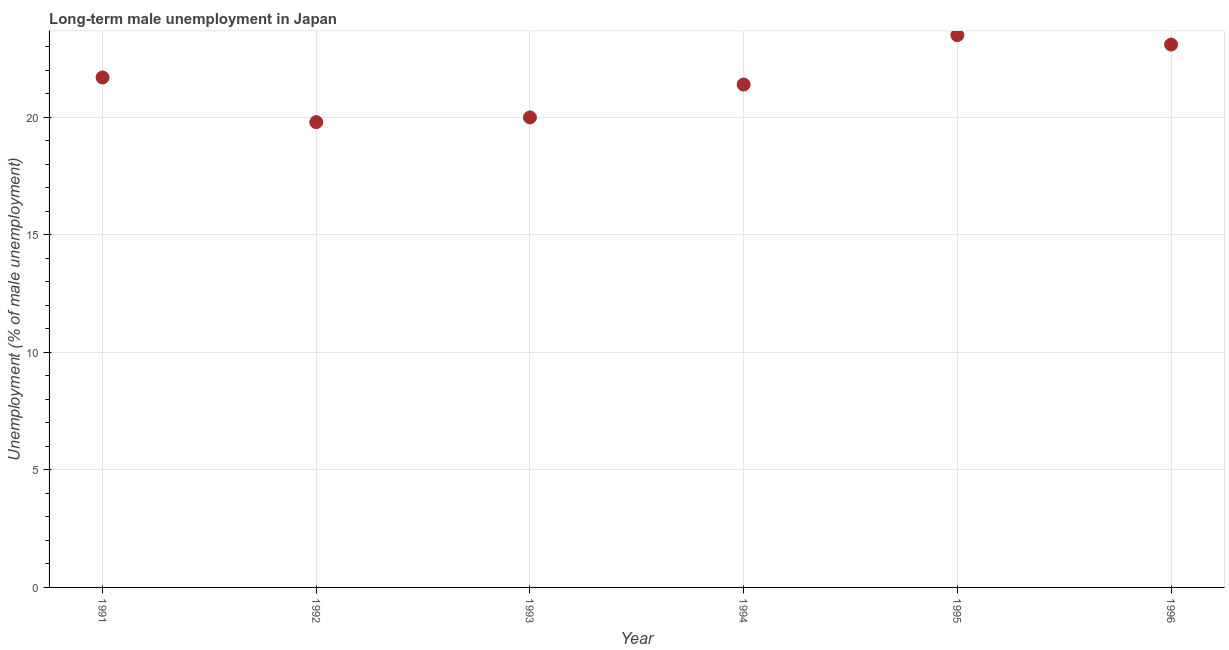What is the long-term male unemployment in 1992?
Provide a short and direct response. 19.8. Across all years, what is the minimum long-term male unemployment?
Your answer should be very brief. 19.8. In which year was the long-term male unemployment maximum?
Make the answer very short. 1995. What is the sum of the long-term male unemployment?
Offer a terse response. 129.5. What is the difference between the long-term male unemployment in 1992 and 1994?
Your answer should be compact. -1.6. What is the average long-term male unemployment per year?
Offer a terse response. 21.58. What is the median long-term male unemployment?
Ensure brevity in your answer.  21.55. Do a majority of the years between 1995 and 1993 (inclusive) have long-term male unemployment greater than 16 %?
Give a very brief answer. No. What is the ratio of the long-term male unemployment in 1991 to that in 1993?
Make the answer very short. 1.09. Is the long-term male unemployment in 1993 less than that in 1996?
Keep it short and to the point. Yes. What is the difference between the highest and the second highest long-term male unemployment?
Your answer should be very brief. 0.4. What is the difference between the highest and the lowest long-term male unemployment?
Provide a short and direct response. 3.7. In how many years, is the long-term male unemployment greater than the average long-term male unemployment taken over all years?
Keep it short and to the point. 3. How many dotlines are there?
Provide a short and direct response. 1. Are the values on the major ticks of Y-axis written in scientific E-notation?
Keep it short and to the point. No. Does the graph contain grids?
Ensure brevity in your answer.  Yes. What is the title of the graph?
Your answer should be compact. Long-term male unemployment in Japan. What is the label or title of the X-axis?
Ensure brevity in your answer.  Year. What is the label or title of the Y-axis?
Offer a terse response. Unemployment (% of male unemployment). What is the Unemployment (% of male unemployment) in 1991?
Provide a short and direct response. 21.7. What is the Unemployment (% of male unemployment) in 1992?
Your response must be concise. 19.8. What is the Unemployment (% of male unemployment) in 1993?
Offer a terse response. 20. What is the Unemployment (% of male unemployment) in 1994?
Provide a succinct answer. 21.4. What is the Unemployment (% of male unemployment) in 1995?
Provide a short and direct response. 23.5. What is the Unemployment (% of male unemployment) in 1996?
Give a very brief answer. 23.1. What is the difference between the Unemployment (% of male unemployment) in 1991 and 1993?
Provide a short and direct response. 1.7. What is the difference between the Unemployment (% of male unemployment) in 1991 and 1994?
Offer a very short reply. 0.3. What is the difference between the Unemployment (% of male unemployment) in 1991 and 1995?
Offer a terse response. -1.8. What is the difference between the Unemployment (% of male unemployment) in 1991 and 1996?
Provide a short and direct response. -1.4. What is the difference between the Unemployment (% of male unemployment) in 1992 and 1994?
Provide a succinct answer. -1.6. What is the difference between the Unemployment (% of male unemployment) in 1992 and 1995?
Give a very brief answer. -3.7. What is the difference between the Unemployment (% of male unemployment) in 1993 and 1996?
Give a very brief answer. -3.1. What is the difference between the Unemployment (% of male unemployment) in 1994 and 1996?
Offer a very short reply. -1.7. What is the difference between the Unemployment (% of male unemployment) in 1995 and 1996?
Your response must be concise. 0.4. What is the ratio of the Unemployment (% of male unemployment) in 1991 to that in 1992?
Keep it short and to the point. 1.1. What is the ratio of the Unemployment (% of male unemployment) in 1991 to that in 1993?
Offer a terse response. 1.08. What is the ratio of the Unemployment (% of male unemployment) in 1991 to that in 1994?
Ensure brevity in your answer.  1.01. What is the ratio of the Unemployment (% of male unemployment) in 1991 to that in 1995?
Make the answer very short. 0.92. What is the ratio of the Unemployment (% of male unemployment) in 1991 to that in 1996?
Give a very brief answer. 0.94. What is the ratio of the Unemployment (% of male unemployment) in 1992 to that in 1993?
Offer a terse response. 0.99. What is the ratio of the Unemployment (% of male unemployment) in 1992 to that in 1994?
Ensure brevity in your answer.  0.93. What is the ratio of the Unemployment (% of male unemployment) in 1992 to that in 1995?
Your answer should be very brief. 0.84. What is the ratio of the Unemployment (% of male unemployment) in 1992 to that in 1996?
Keep it short and to the point. 0.86. What is the ratio of the Unemployment (% of male unemployment) in 1993 to that in 1994?
Ensure brevity in your answer.  0.94. What is the ratio of the Unemployment (% of male unemployment) in 1993 to that in 1995?
Offer a very short reply. 0.85. What is the ratio of the Unemployment (% of male unemployment) in 1993 to that in 1996?
Keep it short and to the point. 0.87. What is the ratio of the Unemployment (% of male unemployment) in 1994 to that in 1995?
Your response must be concise. 0.91. What is the ratio of the Unemployment (% of male unemployment) in 1994 to that in 1996?
Provide a succinct answer. 0.93. What is the ratio of the Unemployment (% of male unemployment) in 1995 to that in 1996?
Keep it short and to the point. 1.02. 